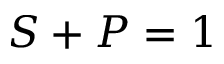<formula> <loc_0><loc_0><loc_500><loc_500>S + P = 1</formula> 